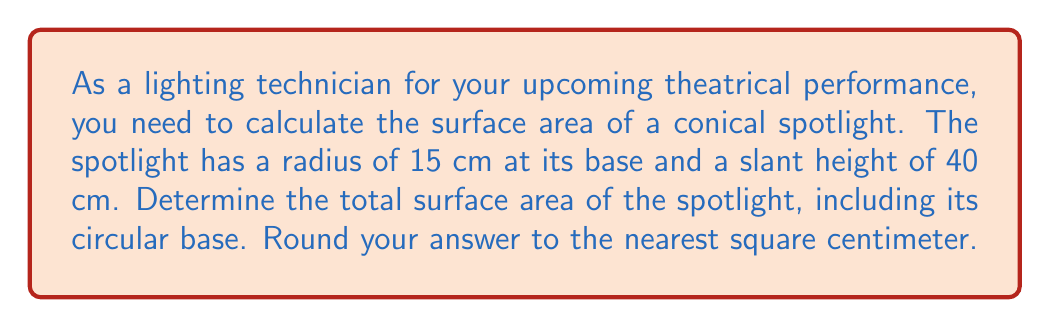Can you answer this question? To solve this problem, we need to calculate the surface area of a cone, which consists of the lateral surface area (the curved part) and the area of the circular base.

1. Let's define our variables:
   $r$ = radius of the base = 15 cm
   $s$ = slant height = 40 cm

2. The formula for the lateral surface area of a cone is:
   $$A_{lateral} = \pi rs$$

3. The formula for the area of the circular base is:
   $$A_{base} = \pi r^2$$

4. The total surface area is the sum of these two:
   $$A_{total} = A_{lateral} + A_{base} = \pi rs + \pi r^2 = \pi r(s + r)$$

5. Let's substitute our values:
   $$A_{total} = \pi \cdot 15 \cdot (40 + 15) = 15\pi \cdot 55 = 825\pi$$

6. Calculate this value:
   $$825\pi \approx 2,592.0530...$$

7. Rounding to the nearest square centimeter:
   $$A_{total} \approx 2,592 \text{ cm}^2$$

[asy]
import geometry;

size(200);
real r = 15;
real h = 38.7298;  // calculated to match slant height of 40

path cone = (0,0)--(r,0)--(0,h)--cycle;
draw(cone);
draw(arc((0,0),r,0,180));
draw((0,0)--(0,h),dashed);
label("15 cm", (r/2,0), S);
label("40 cm", (r,h/2), E);
[/asy]
Answer: The total surface area of the conical spotlight is approximately 2,592 cm². 